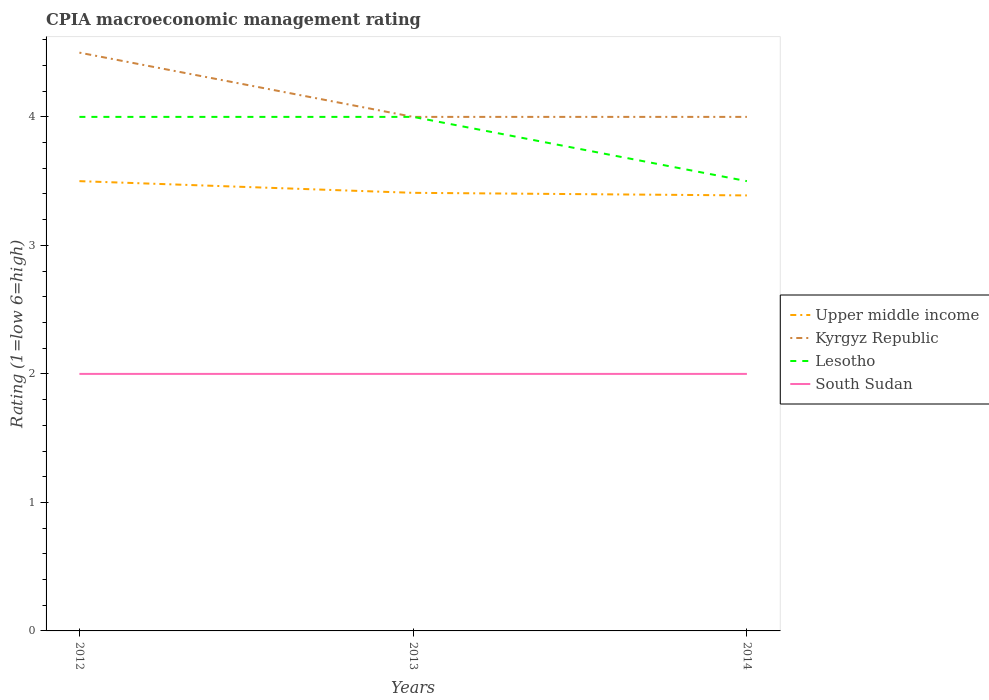Does the line corresponding to Kyrgyz Republic intersect with the line corresponding to Lesotho?
Make the answer very short. Yes. Is the number of lines equal to the number of legend labels?
Offer a very short reply. Yes. Across all years, what is the maximum CPIA rating in Upper middle income?
Your answer should be very brief. 3.39. What is the difference between the highest and the second highest CPIA rating in Lesotho?
Provide a succinct answer. 0.5. Is the CPIA rating in Kyrgyz Republic strictly greater than the CPIA rating in Upper middle income over the years?
Keep it short and to the point. No. How many years are there in the graph?
Your answer should be compact. 3. What is the difference between two consecutive major ticks on the Y-axis?
Offer a very short reply. 1. Are the values on the major ticks of Y-axis written in scientific E-notation?
Offer a terse response. No. How many legend labels are there?
Ensure brevity in your answer.  4. How are the legend labels stacked?
Give a very brief answer. Vertical. What is the title of the graph?
Ensure brevity in your answer.  CPIA macroeconomic management rating. What is the Rating (1=low 6=high) of Upper middle income in 2012?
Your answer should be very brief. 3.5. What is the Rating (1=low 6=high) in Lesotho in 2012?
Ensure brevity in your answer.  4. What is the Rating (1=low 6=high) in South Sudan in 2012?
Provide a succinct answer. 2. What is the Rating (1=low 6=high) of Upper middle income in 2013?
Offer a very short reply. 3.41. What is the Rating (1=low 6=high) in Kyrgyz Republic in 2013?
Provide a succinct answer. 4. What is the Rating (1=low 6=high) of Lesotho in 2013?
Give a very brief answer. 4. What is the Rating (1=low 6=high) in South Sudan in 2013?
Provide a short and direct response. 2. What is the Rating (1=low 6=high) of Upper middle income in 2014?
Keep it short and to the point. 3.39. What is the Rating (1=low 6=high) in Lesotho in 2014?
Provide a short and direct response. 3.5. What is the Rating (1=low 6=high) in South Sudan in 2014?
Ensure brevity in your answer.  2. Across all years, what is the maximum Rating (1=low 6=high) in Upper middle income?
Offer a terse response. 3.5. Across all years, what is the maximum Rating (1=low 6=high) in Kyrgyz Republic?
Your answer should be very brief. 4.5. Across all years, what is the maximum Rating (1=low 6=high) in South Sudan?
Provide a succinct answer. 2. Across all years, what is the minimum Rating (1=low 6=high) of Upper middle income?
Make the answer very short. 3.39. Across all years, what is the minimum Rating (1=low 6=high) of Lesotho?
Make the answer very short. 3.5. Across all years, what is the minimum Rating (1=low 6=high) of South Sudan?
Your answer should be very brief. 2. What is the total Rating (1=low 6=high) in Upper middle income in the graph?
Offer a terse response. 10.3. What is the total Rating (1=low 6=high) of Kyrgyz Republic in the graph?
Offer a terse response. 12.5. What is the total Rating (1=low 6=high) of Lesotho in the graph?
Your answer should be very brief. 11.5. What is the total Rating (1=low 6=high) of South Sudan in the graph?
Provide a succinct answer. 6. What is the difference between the Rating (1=low 6=high) in Upper middle income in 2012 and that in 2013?
Provide a short and direct response. 0.09. What is the difference between the Rating (1=low 6=high) of South Sudan in 2012 and that in 2013?
Offer a terse response. 0. What is the difference between the Rating (1=low 6=high) of Upper middle income in 2012 and that in 2014?
Offer a terse response. 0.11. What is the difference between the Rating (1=low 6=high) of Upper middle income in 2013 and that in 2014?
Keep it short and to the point. 0.02. What is the difference between the Rating (1=low 6=high) in Kyrgyz Republic in 2013 and that in 2014?
Ensure brevity in your answer.  0. What is the difference between the Rating (1=low 6=high) in Lesotho in 2013 and that in 2014?
Your answer should be compact. 0.5. What is the difference between the Rating (1=low 6=high) of South Sudan in 2013 and that in 2014?
Provide a short and direct response. 0. What is the difference between the Rating (1=low 6=high) in Upper middle income in 2012 and the Rating (1=low 6=high) in Lesotho in 2013?
Ensure brevity in your answer.  -0.5. What is the difference between the Rating (1=low 6=high) of Kyrgyz Republic in 2012 and the Rating (1=low 6=high) of Lesotho in 2013?
Give a very brief answer. 0.5. What is the difference between the Rating (1=low 6=high) of Kyrgyz Republic in 2012 and the Rating (1=low 6=high) of South Sudan in 2013?
Keep it short and to the point. 2.5. What is the difference between the Rating (1=low 6=high) of Lesotho in 2012 and the Rating (1=low 6=high) of South Sudan in 2013?
Your answer should be very brief. 2. What is the difference between the Rating (1=low 6=high) in Upper middle income in 2012 and the Rating (1=low 6=high) in Kyrgyz Republic in 2014?
Give a very brief answer. -0.5. What is the difference between the Rating (1=low 6=high) in Kyrgyz Republic in 2012 and the Rating (1=low 6=high) in Lesotho in 2014?
Offer a very short reply. 1. What is the difference between the Rating (1=low 6=high) of Kyrgyz Republic in 2012 and the Rating (1=low 6=high) of South Sudan in 2014?
Give a very brief answer. 2.5. What is the difference between the Rating (1=low 6=high) in Lesotho in 2012 and the Rating (1=low 6=high) in South Sudan in 2014?
Offer a terse response. 2. What is the difference between the Rating (1=low 6=high) in Upper middle income in 2013 and the Rating (1=low 6=high) in Kyrgyz Republic in 2014?
Your answer should be compact. -0.59. What is the difference between the Rating (1=low 6=high) of Upper middle income in 2013 and the Rating (1=low 6=high) of Lesotho in 2014?
Your answer should be very brief. -0.09. What is the difference between the Rating (1=low 6=high) of Upper middle income in 2013 and the Rating (1=low 6=high) of South Sudan in 2014?
Provide a succinct answer. 1.41. What is the difference between the Rating (1=low 6=high) in Kyrgyz Republic in 2013 and the Rating (1=low 6=high) in South Sudan in 2014?
Provide a short and direct response. 2. What is the average Rating (1=low 6=high) of Upper middle income per year?
Your answer should be compact. 3.43. What is the average Rating (1=low 6=high) in Kyrgyz Republic per year?
Provide a succinct answer. 4.17. What is the average Rating (1=low 6=high) in Lesotho per year?
Offer a very short reply. 3.83. In the year 2012, what is the difference between the Rating (1=low 6=high) in Upper middle income and Rating (1=low 6=high) in Kyrgyz Republic?
Keep it short and to the point. -1. In the year 2012, what is the difference between the Rating (1=low 6=high) of Kyrgyz Republic and Rating (1=low 6=high) of Lesotho?
Keep it short and to the point. 0.5. In the year 2012, what is the difference between the Rating (1=low 6=high) in Kyrgyz Republic and Rating (1=low 6=high) in South Sudan?
Ensure brevity in your answer.  2.5. In the year 2012, what is the difference between the Rating (1=low 6=high) of Lesotho and Rating (1=low 6=high) of South Sudan?
Your answer should be compact. 2. In the year 2013, what is the difference between the Rating (1=low 6=high) of Upper middle income and Rating (1=low 6=high) of Kyrgyz Republic?
Your answer should be compact. -0.59. In the year 2013, what is the difference between the Rating (1=low 6=high) in Upper middle income and Rating (1=low 6=high) in Lesotho?
Offer a very short reply. -0.59. In the year 2013, what is the difference between the Rating (1=low 6=high) of Upper middle income and Rating (1=low 6=high) of South Sudan?
Keep it short and to the point. 1.41. In the year 2013, what is the difference between the Rating (1=low 6=high) in Kyrgyz Republic and Rating (1=low 6=high) in Lesotho?
Make the answer very short. 0. In the year 2013, what is the difference between the Rating (1=low 6=high) in Kyrgyz Republic and Rating (1=low 6=high) in South Sudan?
Provide a short and direct response. 2. In the year 2014, what is the difference between the Rating (1=low 6=high) in Upper middle income and Rating (1=low 6=high) in Kyrgyz Republic?
Give a very brief answer. -0.61. In the year 2014, what is the difference between the Rating (1=low 6=high) of Upper middle income and Rating (1=low 6=high) of Lesotho?
Provide a succinct answer. -0.11. In the year 2014, what is the difference between the Rating (1=low 6=high) in Upper middle income and Rating (1=low 6=high) in South Sudan?
Your answer should be very brief. 1.39. In the year 2014, what is the difference between the Rating (1=low 6=high) of Kyrgyz Republic and Rating (1=low 6=high) of Lesotho?
Give a very brief answer. 0.5. In the year 2014, what is the difference between the Rating (1=low 6=high) in Kyrgyz Republic and Rating (1=low 6=high) in South Sudan?
Your answer should be very brief. 2. In the year 2014, what is the difference between the Rating (1=low 6=high) of Lesotho and Rating (1=low 6=high) of South Sudan?
Your answer should be very brief. 1.5. What is the ratio of the Rating (1=low 6=high) in Upper middle income in 2012 to that in 2013?
Provide a succinct answer. 1.03. What is the ratio of the Rating (1=low 6=high) of South Sudan in 2012 to that in 2013?
Offer a very short reply. 1. What is the ratio of the Rating (1=low 6=high) of Upper middle income in 2012 to that in 2014?
Ensure brevity in your answer.  1.03. What is the ratio of the Rating (1=low 6=high) in Kyrgyz Republic in 2012 to that in 2014?
Your answer should be very brief. 1.12. What is the ratio of the Rating (1=low 6=high) in Lesotho in 2013 to that in 2014?
Ensure brevity in your answer.  1.14. What is the difference between the highest and the second highest Rating (1=low 6=high) in Upper middle income?
Your response must be concise. 0.09. What is the difference between the highest and the second highest Rating (1=low 6=high) in Lesotho?
Make the answer very short. 0. What is the difference between the highest and the lowest Rating (1=low 6=high) in Upper middle income?
Provide a succinct answer. 0.11. What is the difference between the highest and the lowest Rating (1=low 6=high) in Kyrgyz Republic?
Your response must be concise. 0.5. What is the difference between the highest and the lowest Rating (1=low 6=high) of South Sudan?
Offer a very short reply. 0. 